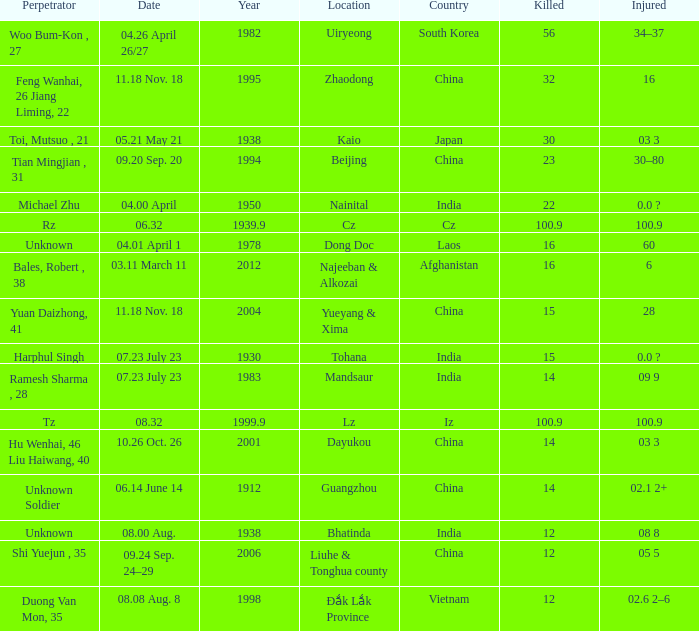What is the average Year, when Date is "04.01 April 1"? 1978.0. 